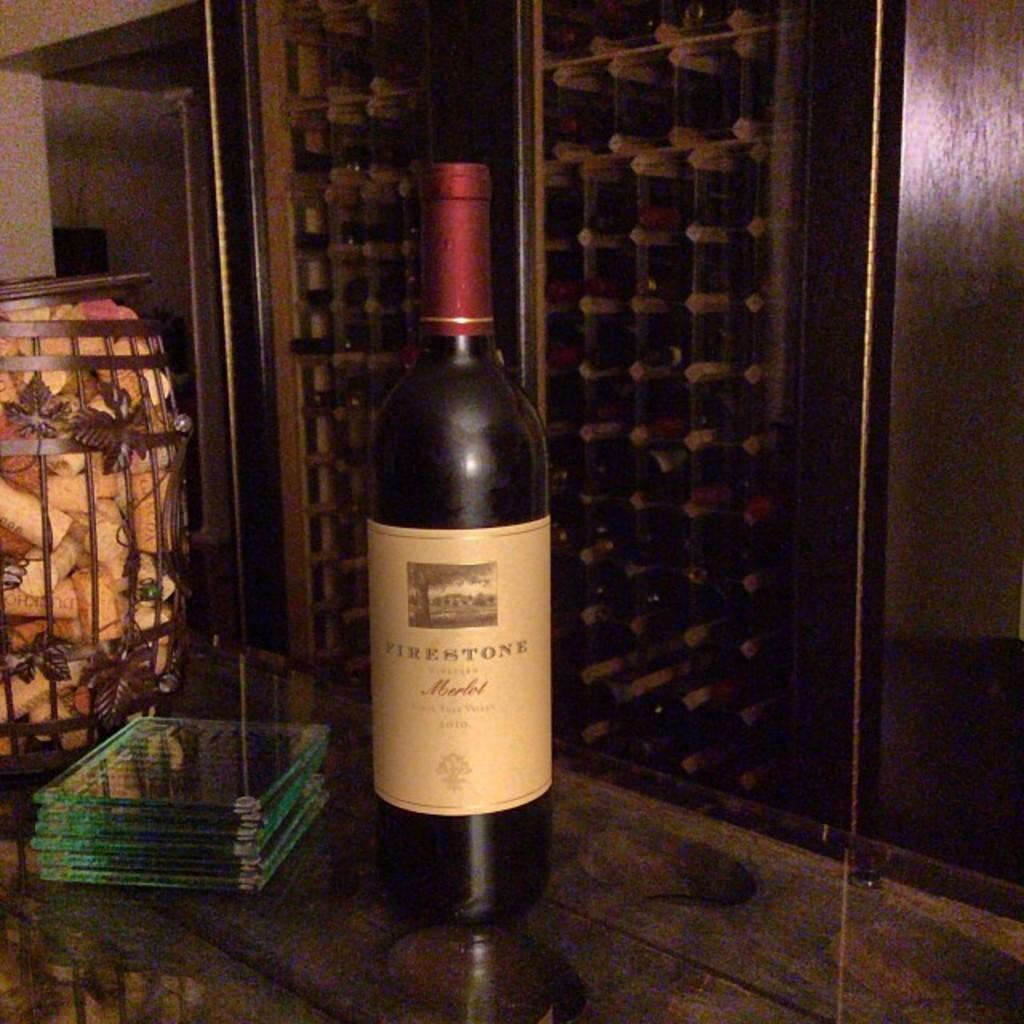<image>
Describe the image concisely. A bottle of Firestone Merlot sits on a table in front of other bottles of wine 